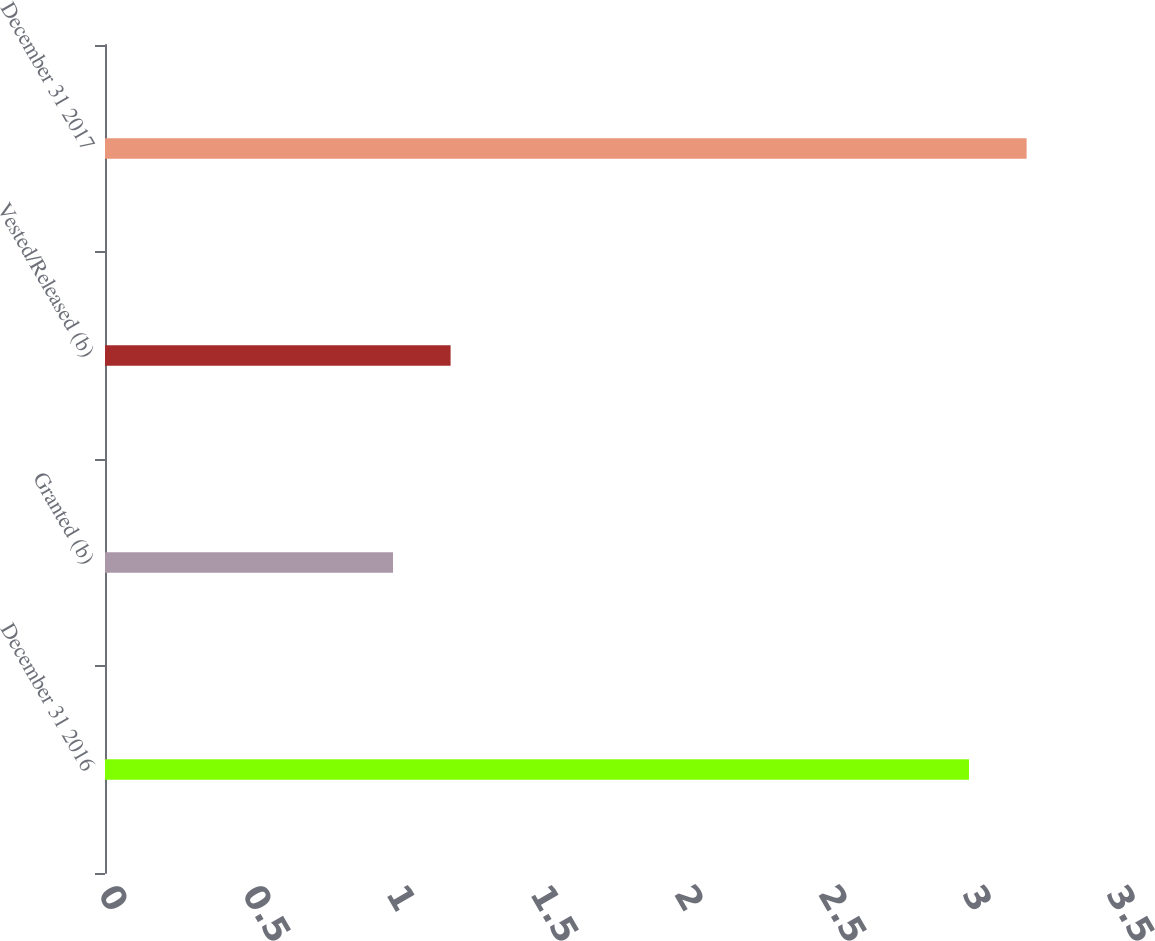Convert chart. <chart><loc_0><loc_0><loc_500><loc_500><bar_chart><fcel>December 31 2016<fcel>Granted (b)<fcel>Vested/Released (b)<fcel>December 31 2017<nl><fcel>3<fcel>1<fcel>1.2<fcel>3.2<nl></chart> 